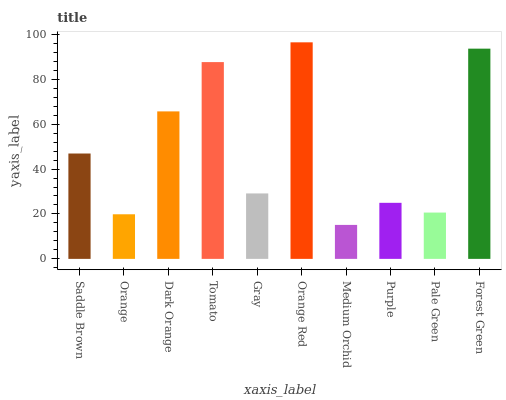Is Medium Orchid the minimum?
Answer yes or no. Yes. Is Orange Red the maximum?
Answer yes or no. Yes. Is Orange the minimum?
Answer yes or no. No. Is Orange the maximum?
Answer yes or no. No. Is Saddle Brown greater than Orange?
Answer yes or no. Yes. Is Orange less than Saddle Brown?
Answer yes or no. Yes. Is Orange greater than Saddle Brown?
Answer yes or no. No. Is Saddle Brown less than Orange?
Answer yes or no. No. Is Saddle Brown the high median?
Answer yes or no. Yes. Is Gray the low median?
Answer yes or no. Yes. Is Orange Red the high median?
Answer yes or no. No. Is Orange Red the low median?
Answer yes or no. No. 